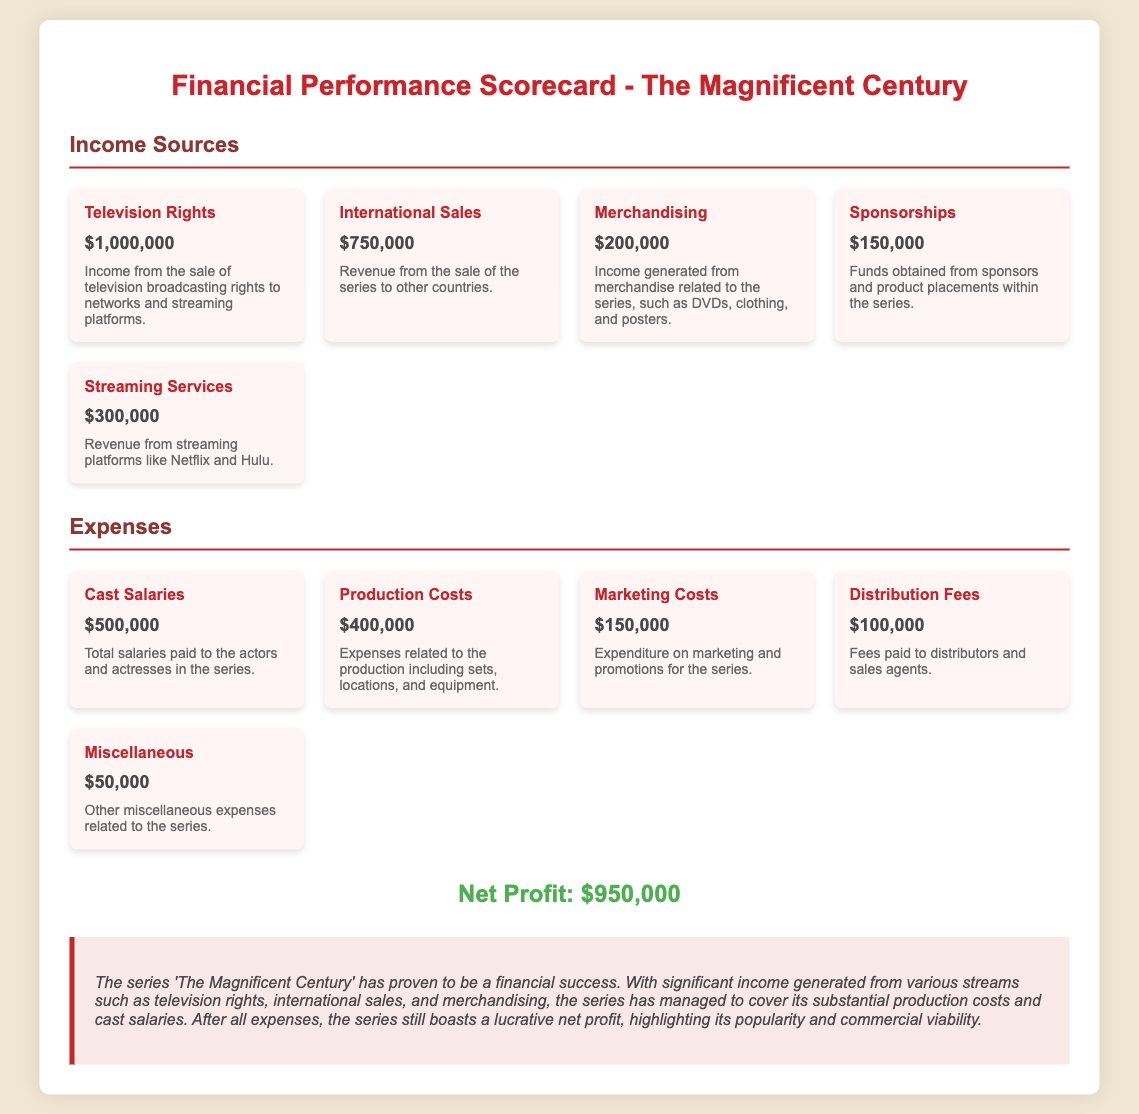What is the income from television rights? The income from television rights is listed as a specific figure in the document.
Answer: $1,000,000 What is the total amount spent on cast salaries? The total spent on cast salaries is a specific expense mentioned in the document.
Answer: $500,000 How much revenue was generated from merchandising? The revenue from merchandising is detailed in the income sources section of the document.
Answer: $200,000 What are the total expenses for marketing costs? The total expenses for marketing costs are specifically stated in the expenses section of the document.
Answer: $150,000 What is the net profit reported for the series? The net profit is specifically highlighted at the bottom of the document.
Answer: $950,000 How much income was generated from international sales? The income from international sales is provided in the income sources section of the document.
Answer: $750,000 What is the total income from streaming services? The total income from streaming services is one of the figures shown in the income sources section.
Answer: $300,000 What is the combined total of all expenses listed? The combined total is derived from adding all expenses detailed in the expense section of the document.
Answer: $1,200,000 Which source generated the highest income? The source generating the highest income is clearly specified in the income sources section.
Answer: Television Rights 